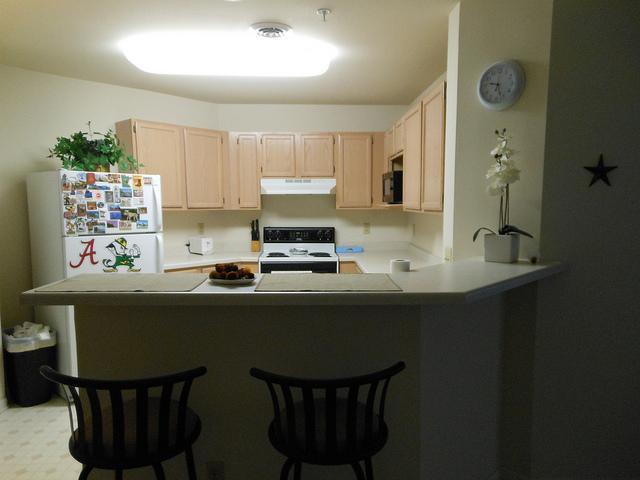How many seats are there?
Give a very brief answer. 2. How many chairs are in the picture?
Give a very brief answer. 2. How many potted plants are there?
Give a very brief answer. 2. 